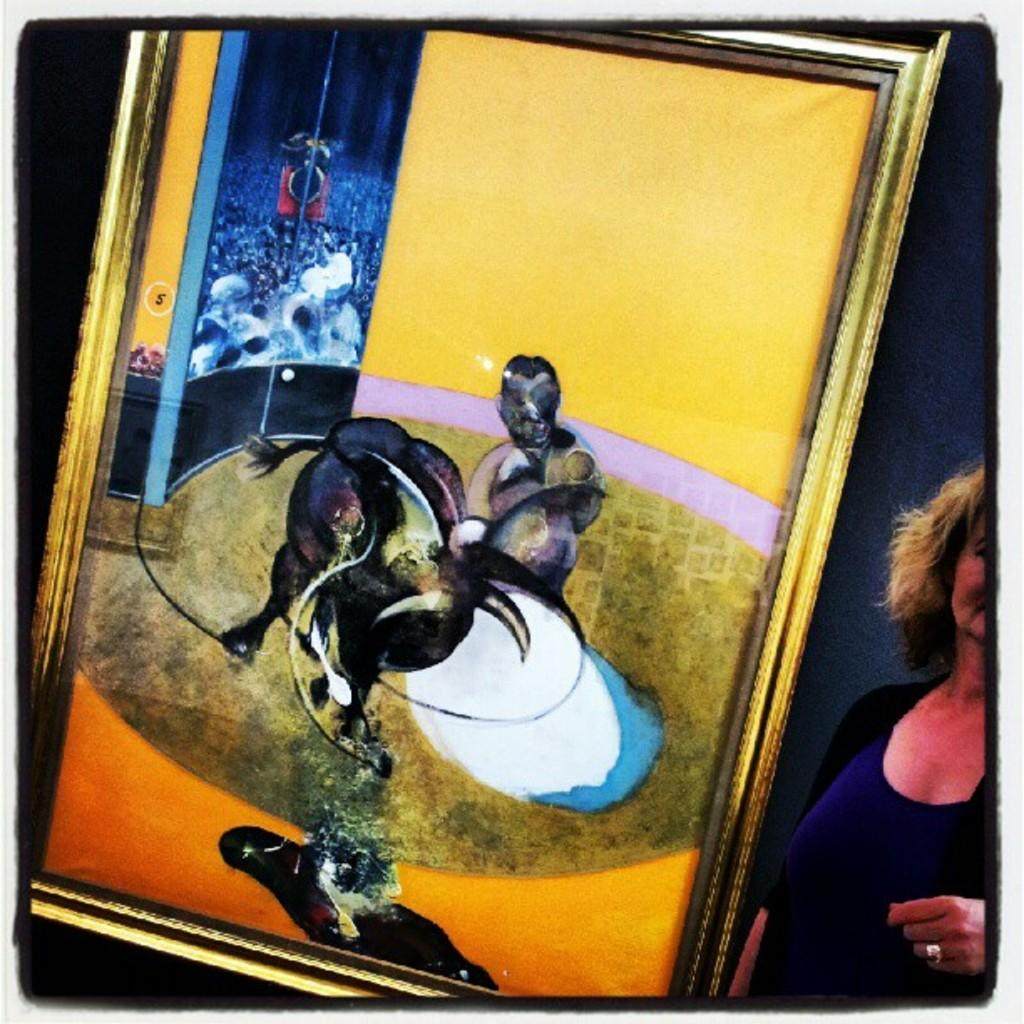What is hanging on the wall in the image? There is a painting with a frame on the wall in the image. Can you describe the woman on the right side of the image? Unfortunately, the provided facts do not give any information about the woman's appearance or actions. What is the subject matter of the painting on the wall? The provided facts do not give any information about the painting's subject matter. Reasoning: Let's think step by step by step in order to produce the conversation. We start by identifying the main subjects and objects in the image based on the provided facts. We then formulate questions that focus on the location and characteristics of these subjects and objects, ensuring that each question can be answered definitively with the information given. We avoid yes/no questions and ensure that the language is simple and clear. Absurd Question/Answer: What type of feast is being prepared in the image? There is no indication of a feast or any food preparation in the image. What question is the woman asking in the image? The provided facts do not give any information about the woman's actions or what she might be saying. What type of flight is the woman taking in the image? There is no indication of a flight or any travel-related activity in the image. 